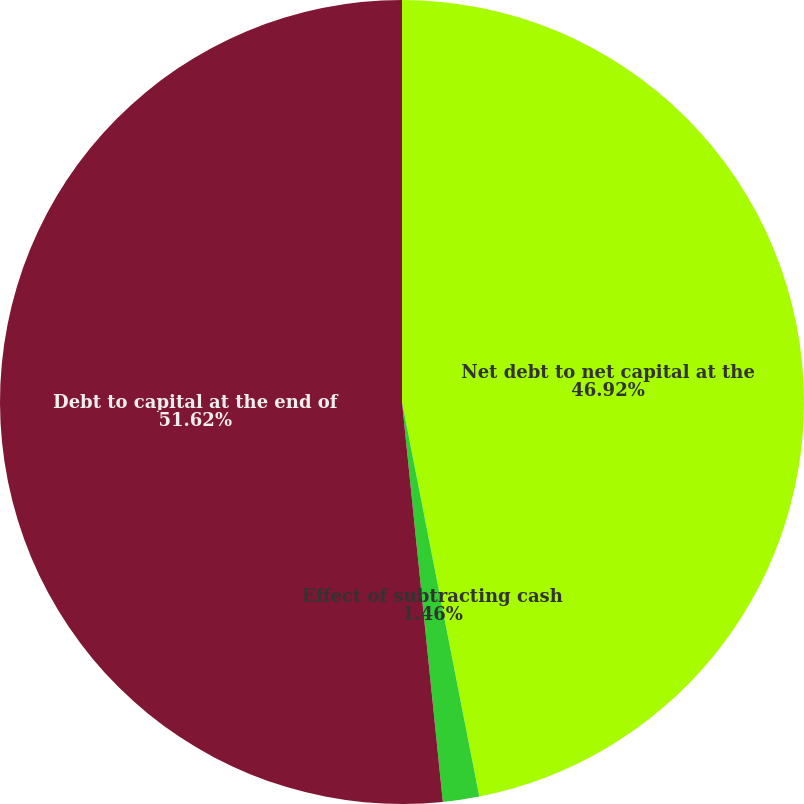Convert chart to OTSL. <chart><loc_0><loc_0><loc_500><loc_500><pie_chart><fcel>Net debt to net capital at the<fcel>Effect of subtracting cash<fcel>Debt to capital at the end of<nl><fcel>46.92%<fcel>1.46%<fcel>51.62%<nl></chart> 